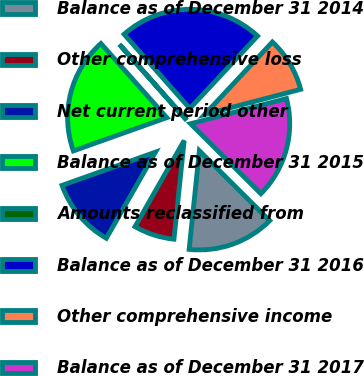Convert chart. <chart><loc_0><loc_0><loc_500><loc_500><pie_chart><fcel>Balance as of December 31 2014<fcel>Other comprehensive loss<fcel>Net current period other<fcel>Balance as of December 31 2015<fcel>Amounts reclassified from<fcel>Balance as of December 31 2016<fcel>Other comprehensive income<fcel>Balance as of December 31 2017<nl><fcel>14.19%<fcel>6.61%<fcel>11.3%<fcel>18.88%<fcel>0.03%<fcel>23.49%<fcel>8.96%<fcel>16.54%<nl></chart> 